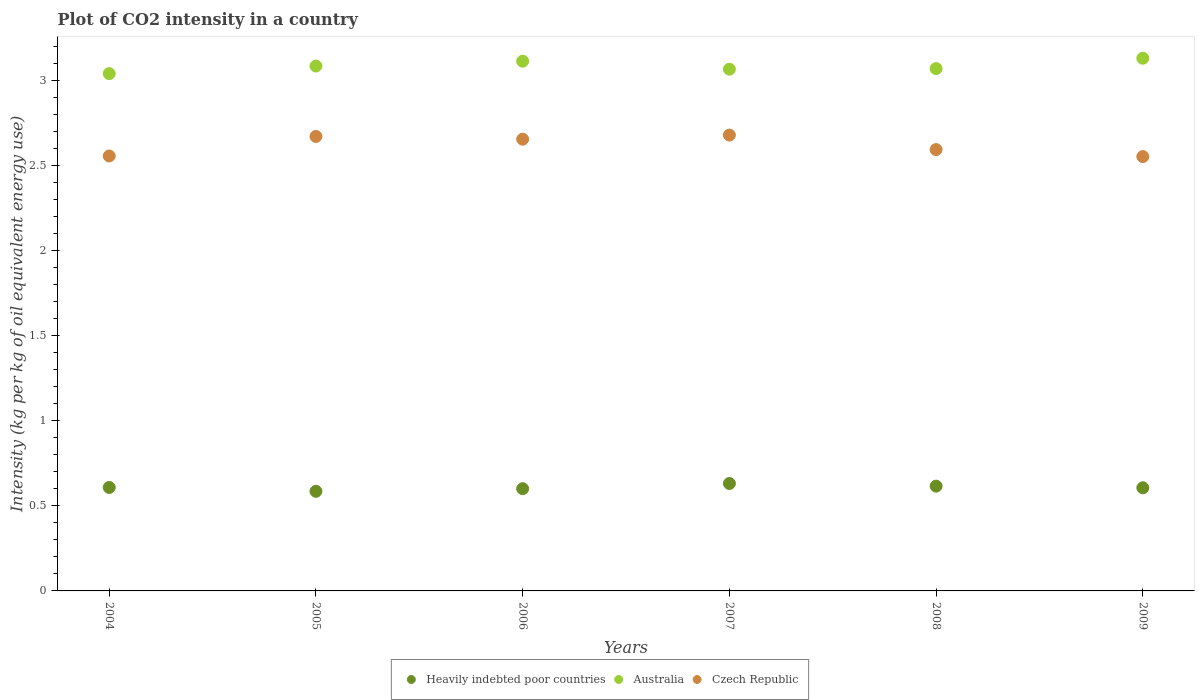Is the number of dotlines equal to the number of legend labels?
Give a very brief answer. Yes. What is the CO2 intensity in in Heavily indebted poor countries in 2009?
Make the answer very short. 0.61. Across all years, what is the maximum CO2 intensity in in Australia?
Give a very brief answer. 3.13. Across all years, what is the minimum CO2 intensity in in Czech Republic?
Give a very brief answer. 2.55. In which year was the CO2 intensity in in Heavily indebted poor countries maximum?
Offer a terse response. 2007. In which year was the CO2 intensity in in Australia minimum?
Offer a very short reply. 2004. What is the total CO2 intensity in in Australia in the graph?
Keep it short and to the point. 18.52. What is the difference between the CO2 intensity in in Czech Republic in 2008 and that in 2009?
Your response must be concise. 0.04. What is the difference between the CO2 intensity in in Czech Republic in 2004 and the CO2 intensity in in Australia in 2007?
Your answer should be very brief. -0.51. What is the average CO2 intensity in in Heavily indebted poor countries per year?
Your answer should be compact. 0.61. In the year 2007, what is the difference between the CO2 intensity in in Czech Republic and CO2 intensity in in Heavily indebted poor countries?
Offer a very short reply. 2.05. What is the ratio of the CO2 intensity in in Czech Republic in 2004 to that in 2006?
Give a very brief answer. 0.96. What is the difference between the highest and the second highest CO2 intensity in in Heavily indebted poor countries?
Offer a terse response. 0.02. What is the difference between the highest and the lowest CO2 intensity in in Australia?
Your answer should be very brief. 0.09. In how many years, is the CO2 intensity in in Heavily indebted poor countries greater than the average CO2 intensity in in Heavily indebted poor countries taken over all years?
Your response must be concise. 3. Is it the case that in every year, the sum of the CO2 intensity in in Australia and CO2 intensity in in Heavily indebted poor countries  is greater than the CO2 intensity in in Czech Republic?
Provide a short and direct response. Yes. How many dotlines are there?
Ensure brevity in your answer.  3. Does the graph contain any zero values?
Your answer should be very brief. No. What is the title of the graph?
Your answer should be compact. Plot of CO2 intensity in a country. What is the label or title of the Y-axis?
Give a very brief answer. Intensity (kg per kg of oil equivalent energy use). What is the Intensity (kg per kg of oil equivalent energy use) of Heavily indebted poor countries in 2004?
Offer a terse response. 0.61. What is the Intensity (kg per kg of oil equivalent energy use) in Australia in 2004?
Provide a succinct answer. 3.04. What is the Intensity (kg per kg of oil equivalent energy use) of Czech Republic in 2004?
Keep it short and to the point. 2.56. What is the Intensity (kg per kg of oil equivalent energy use) of Heavily indebted poor countries in 2005?
Your answer should be very brief. 0.59. What is the Intensity (kg per kg of oil equivalent energy use) of Australia in 2005?
Your answer should be very brief. 3.09. What is the Intensity (kg per kg of oil equivalent energy use) of Czech Republic in 2005?
Offer a very short reply. 2.67. What is the Intensity (kg per kg of oil equivalent energy use) of Heavily indebted poor countries in 2006?
Your response must be concise. 0.6. What is the Intensity (kg per kg of oil equivalent energy use) in Australia in 2006?
Provide a short and direct response. 3.12. What is the Intensity (kg per kg of oil equivalent energy use) of Czech Republic in 2006?
Offer a very short reply. 2.66. What is the Intensity (kg per kg of oil equivalent energy use) of Heavily indebted poor countries in 2007?
Give a very brief answer. 0.63. What is the Intensity (kg per kg of oil equivalent energy use) of Australia in 2007?
Ensure brevity in your answer.  3.07. What is the Intensity (kg per kg of oil equivalent energy use) in Czech Republic in 2007?
Provide a succinct answer. 2.68. What is the Intensity (kg per kg of oil equivalent energy use) in Heavily indebted poor countries in 2008?
Offer a terse response. 0.62. What is the Intensity (kg per kg of oil equivalent energy use) of Australia in 2008?
Provide a short and direct response. 3.07. What is the Intensity (kg per kg of oil equivalent energy use) of Czech Republic in 2008?
Keep it short and to the point. 2.6. What is the Intensity (kg per kg of oil equivalent energy use) of Heavily indebted poor countries in 2009?
Provide a succinct answer. 0.61. What is the Intensity (kg per kg of oil equivalent energy use) of Australia in 2009?
Ensure brevity in your answer.  3.13. What is the Intensity (kg per kg of oil equivalent energy use) of Czech Republic in 2009?
Your response must be concise. 2.55. Across all years, what is the maximum Intensity (kg per kg of oil equivalent energy use) in Heavily indebted poor countries?
Ensure brevity in your answer.  0.63. Across all years, what is the maximum Intensity (kg per kg of oil equivalent energy use) in Australia?
Offer a very short reply. 3.13. Across all years, what is the maximum Intensity (kg per kg of oil equivalent energy use) in Czech Republic?
Your response must be concise. 2.68. Across all years, what is the minimum Intensity (kg per kg of oil equivalent energy use) in Heavily indebted poor countries?
Provide a short and direct response. 0.59. Across all years, what is the minimum Intensity (kg per kg of oil equivalent energy use) of Australia?
Keep it short and to the point. 3.04. Across all years, what is the minimum Intensity (kg per kg of oil equivalent energy use) in Czech Republic?
Make the answer very short. 2.55. What is the total Intensity (kg per kg of oil equivalent energy use) in Heavily indebted poor countries in the graph?
Your answer should be very brief. 3.65. What is the total Intensity (kg per kg of oil equivalent energy use) in Australia in the graph?
Provide a short and direct response. 18.52. What is the total Intensity (kg per kg of oil equivalent energy use) of Czech Republic in the graph?
Your response must be concise. 15.72. What is the difference between the Intensity (kg per kg of oil equivalent energy use) in Heavily indebted poor countries in 2004 and that in 2005?
Give a very brief answer. 0.02. What is the difference between the Intensity (kg per kg of oil equivalent energy use) of Australia in 2004 and that in 2005?
Keep it short and to the point. -0.04. What is the difference between the Intensity (kg per kg of oil equivalent energy use) in Czech Republic in 2004 and that in 2005?
Ensure brevity in your answer.  -0.11. What is the difference between the Intensity (kg per kg of oil equivalent energy use) in Heavily indebted poor countries in 2004 and that in 2006?
Your answer should be very brief. 0.01. What is the difference between the Intensity (kg per kg of oil equivalent energy use) of Australia in 2004 and that in 2006?
Offer a terse response. -0.07. What is the difference between the Intensity (kg per kg of oil equivalent energy use) in Czech Republic in 2004 and that in 2006?
Your answer should be compact. -0.1. What is the difference between the Intensity (kg per kg of oil equivalent energy use) in Heavily indebted poor countries in 2004 and that in 2007?
Provide a succinct answer. -0.02. What is the difference between the Intensity (kg per kg of oil equivalent energy use) in Australia in 2004 and that in 2007?
Your response must be concise. -0.03. What is the difference between the Intensity (kg per kg of oil equivalent energy use) in Czech Republic in 2004 and that in 2007?
Ensure brevity in your answer.  -0.12. What is the difference between the Intensity (kg per kg of oil equivalent energy use) in Heavily indebted poor countries in 2004 and that in 2008?
Offer a terse response. -0.01. What is the difference between the Intensity (kg per kg of oil equivalent energy use) of Australia in 2004 and that in 2008?
Provide a succinct answer. -0.03. What is the difference between the Intensity (kg per kg of oil equivalent energy use) in Czech Republic in 2004 and that in 2008?
Give a very brief answer. -0.04. What is the difference between the Intensity (kg per kg of oil equivalent energy use) of Heavily indebted poor countries in 2004 and that in 2009?
Your response must be concise. 0. What is the difference between the Intensity (kg per kg of oil equivalent energy use) in Australia in 2004 and that in 2009?
Make the answer very short. -0.09. What is the difference between the Intensity (kg per kg of oil equivalent energy use) of Czech Republic in 2004 and that in 2009?
Your response must be concise. 0. What is the difference between the Intensity (kg per kg of oil equivalent energy use) in Heavily indebted poor countries in 2005 and that in 2006?
Your answer should be very brief. -0.02. What is the difference between the Intensity (kg per kg of oil equivalent energy use) in Australia in 2005 and that in 2006?
Make the answer very short. -0.03. What is the difference between the Intensity (kg per kg of oil equivalent energy use) of Czech Republic in 2005 and that in 2006?
Give a very brief answer. 0.02. What is the difference between the Intensity (kg per kg of oil equivalent energy use) in Heavily indebted poor countries in 2005 and that in 2007?
Keep it short and to the point. -0.05. What is the difference between the Intensity (kg per kg of oil equivalent energy use) in Australia in 2005 and that in 2007?
Your answer should be very brief. 0.02. What is the difference between the Intensity (kg per kg of oil equivalent energy use) in Czech Republic in 2005 and that in 2007?
Make the answer very short. -0.01. What is the difference between the Intensity (kg per kg of oil equivalent energy use) of Heavily indebted poor countries in 2005 and that in 2008?
Provide a succinct answer. -0.03. What is the difference between the Intensity (kg per kg of oil equivalent energy use) in Australia in 2005 and that in 2008?
Provide a short and direct response. 0.01. What is the difference between the Intensity (kg per kg of oil equivalent energy use) in Czech Republic in 2005 and that in 2008?
Your answer should be very brief. 0.08. What is the difference between the Intensity (kg per kg of oil equivalent energy use) in Heavily indebted poor countries in 2005 and that in 2009?
Make the answer very short. -0.02. What is the difference between the Intensity (kg per kg of oil equivalent energy use) of Australia in 2005 and that in 2009?
Your answer should be very brief. -0.05. What is the difference between the Intensity (kg per kg of oil equivalent energy use) of Czech Republic in 2005 and that in 2009?
Ensure brevity in your answer.  0.12. What is the difference between the Intensity (kg per kg of oil equivalent energy use) of Heavily indebted poor countries in 2006 and that in 2007?
Your answer should be compact. -0.03. What is the difference between the Intensity (kg per kg of oil equivalent energy use) of Australia in 2006 and that in 2007?
Offer a terse response. 0.05. What is the difference between the Intensity (kg per kg of oil equivalent energy use) of Czech Republic in 2006 and that in 2007?
Offer a terse response. -0.02. What is the difference between the Intensity (kg per kg of oil equivalent energy use) in Heavily indebted poor countries in 2006 and that in 2008?
Offer a terse response. -0.01. What is the difference between the Intensity (kg per kg of oil equivalent energy use) in Australia in 2006 and that in 2008?
Your answer should be compact. 0.04. What is the difference between the Intensity (kg per kg of oil equivalent energy use) in Czech Republic in 2006 and that in 2008?
Keep it short and to the point. 0.06. What is the difference between the Intensity (kg per kg of oil equivalent energy use) in Heavily indebted poor countries in 2006 and that in 2009?
Give a very brief answer. -0.01. What is the difference between the Intensity (kg per kg of oil equivalent energy use) in Australia in 2006 and that in 2009?
Your response must be concise. -0.02. What is the difference between the Intensity (kg per kg of oil equivalent energy use) in Czech Republic in 2006 and that in 2009?
Provide a short and direct response. 0.1. What is the difference between the Intensity (kg per kg of oil equivalent energy use) of Heavily indebted poor countries in 2007 and that in 2008?
Provide a succinct answer. 0.02. What is the difference between the Intensity (kg per kg of oil equivalent energy use) in Australia in 2007 and that in 2008?
Your answer should be very brief. -0. What is the difference between the Intensity (kg per kg of oil equivalent energy use) of Czech Republic in 2007 and that in 2008?
Your response must be concise. 0.09. What is the difference between the Intensity (kg per kg of oil equivalent energy use) of Heavily indebted poor countries in 2007 and that in 2009?
Ensure brevity in your answer.  0.03. What is the difference between the Intensity (kg per kg of oil equivalent energy use) of Australia in 2007 and that in 2009?
Provide a short and direct response. -0.06. What is the difference between the Intensity (kg per kg of oil equivalent energy use) of Czech Republic in 2007 and that in 2009?
Give a very brief answer. 0.13. What is the difference between the Intensity (kg per kg of oil equivalent energy use) of Heavily indebted poor countries in 2008 and that in 2009?
Your answer should be very brief. 0.01. What is the difference between the Intensity (kg per kg of oil equivalent energy use) of Australia in 2008 and that in 2009?
Offer a terse response. -0.06. What is the difference between the Intensity (kg per kg of oil equivalent energy use) of Czech Republic in 2008 and that in 2009?
Give a very brief answer. 0.04. What is the difference between the Intensity (kg per kg of oil equivalent energy use) of Heavily indebted poor countries in 2004 and the Intensity (kg per kg of oil equivalent energy use) of Australia in 2005?
Provide a succinct answer. -2.48. What is the difference between the Intensity (kg per kg of oil equivalent energy use) in Heavily indebted poor countries in 2004 and the Intensity (kg per kg of oil equivalent energy use) in Czech Republic in 2005?
Give a very brief answer. -2.06. What is the difference between the Intensity (kg per kg of oil equivalent energy use) of Australia in 2004 and the Intensity (kg per kg of oil equivalent energy use) of Czech Republic in 2005?
Give a very brief answer. 0.37. What is the difference between the Intensity (kg per kg of oil equivalent energy use) in Heavily indebted poor countries in 2004 and the Intensity (kg per kg of oil equivalent energy use) in Australia in 2006?
Offer a very short reply. -2.51. What is the difference between the Intensity (kg per kg of oil equivalent energy use) of Heavily indebted poor countries in 2004 and the Intensity (kg per kg of oil equivalent energy use) of Czech Republic in 2006?
Provide a succinct answer. -2.05. What is the difference between the Intensity (kg per kg of oil equivalent energy use) of Australia in 2004 and the Intensity (kg per kg of oil equivalent energy use) of Czech Republic in 2006?
Keep it short and to the point. 0.39. What is the difference between the Intensity (kg per kg of oil equivalent energy use) in Heavily indebted poor countries in 2004 and the Intensity (kg per kg of oil equivalent energy use) in Australia in 2007?
Offer a very short reply. -2.46. What is the difference between the Intensity (kg per kg of oil equivalent energy use) of Heavily indebted poor countries in 2004 and the Intensity (kg per kg of oil equivalent energy use) of Czech Republic in 2007?
Make the answer very short. -2.07. What is the difference between the Intensity (kg per kg of oil equivalent energy use) of Australia in 2004 and the Intensity (kg per kg of oil equivalent energy use) of Czech Republic in 2007?
Keep it short and to the point. 0.36. What is the difference between the Intensity (kg per kg of oil equivalent energy use) in Heavily indebted poor countries in 2004 and the Intensity (kg per kg of oil equivalent energy use) in Australia in 2008?
Make the answer very short. -2.46. What is the difference between the Intensity (kg per kg of oil equivalent energy use) of Heavily indebted poor countries in 2004 and the Intensity (kg per kg of oil equivalent energy use) of Czech Republic in 2008?
Offer a terse response. -1.99. What is the difference between the Intensity (kg per kg of oil equivalent energy use) in Australia in 2004 and the Intensity (kg per kg of oil equivalent energy use) in Czech Republic in 2008?
Your answer should be compact. 0.45. What is the difference between the Intensity (kg per kg of oil equivalent energy use) of Heavily indebted poor countries in 2004 and the Intensity (kg per kg of oil equivalent energy use) of Australia in 2009?
Offer a very short reply. -2.52. What is the difference between the Intensity (kg per kg of oil equivalent energy use) in Heavily indebted poor countries in 2004 and the Intensity (kg per kg of oil equivalent energy use) in Czech Republic in 2009?
Your answer should be compact. -1.95. What is the difference between the Intensity (kg per kg of oil equivalent energy use) of Australia in 2004 and the Intensity (kg per kg of oil equivalent energy use) of Czech Republic in 2009?
Offer a terse response. 0.49. What is the difference between the Intensity (kg per kg of oil equivalent energy use) in Heavily indebted poor countries in 2005 and the Intensity (kg per kg of oil equivalent energy use) in Australia in 2006?
Keep it short and to the point. -2.53. What is the difference between the Intensity (kg per kg of oil equivalent energy use) in Heavily indebted poor countries in 2005 and the Intensity (kg per kg of oil equivalent energy use) in Czech Republic in 2006?
Your response must be concise. -2.07. What is the difference between the Intensity (kg per kg of oil equivalent energy use) in Australia in 2005 and the Intensity (kg per kg of oil equivalent energy use) in Czech Republic in 2006?
Keep it short and to the point. 0.43. What is the difference between the Intensity (kg per kg of oil equivalent energy use) of Heavily indebted poor countries in 2005 and the Intensity (kg per kg of oil equivalent energy use) of Australia in 2007?
Give a very brief answer. -2.48. What is the difference between the Intensity (kg per kg of oil equivalent energy use) of Heavily indebted poor countries in 2005 and the Intensity (kg per kg of oil equivalent energy use) of Czech Republic in 2007?
Ensure brevity in your answer.  -2.1. What is the difference between the Intensity (kg per kg of oil equivalent energy use) of Australia in 2005 and the Intensity (kg per kg of oil equivalent energy use) of Czech Republic in 2007?
Offer a very short reply. 0.41. What is the difference between the Intensity (kg per kg of oil equivalent energy use) in Heavily indebted poor countries in 2005 and the Intensity (kg per kg of oil equivalent energy use) in Australia in 2008?
Ensure brevity in your answer.  -2.49. What is the difference between the Intensity (kg per kg of oil equivalent energy use) in Heavily indebted poor countries in 2005 and the Intensity (kg per kg of oil equivalent energy use) in Czech Republic in 2008?
Offer a terse response. -2.01. What is the difference between the Intensity (kg per kg of oil equivalent energy use) of Australia in 2005 and the Intensity (kg per kg of oil equivalent energy use) of Czech Republic in 2008?
Offer a very short reply. 0.49. What is the difference between the Intensity (kg per kg of oil equivalent energy use) in Heavily indebted poor countries in 2005 and the Intensity (kg per kg of oil equivalent energy use) in Australia in 2009?
Keep it short and to the point. -2.55. What is the difference between the Intensity (kg per kg of oil equivalent energy use) in Heavily indebted poor countries in 2005 and the Intensity (kg per kg of oil equivalent energy use) in Czech Republic in 2009?
Provide a succinct answer. -1.97. What is the difference between the Intensity (kg per kg of oil equivalent energy use) of Australia in 2005 and the Intensity (kg per kg of oil equivalent energy use) of Czech Republic in 2009?
Provide a succinct answer. 0.53. What is the difference between the Intensity (kg per kg of oil equivalent energy use) of Heavily indebted poor countries in 2006 and the Intensity (kg per kg of oil equivalent energy use) of Australia in 2007?
Provide a succinct answer. -2.47. What is the difference between the Intensity (kg per kg of oil equivalent energy use) in Heavily indebted poor countries in 2006 and the Intensity (kg per kg of oil equivalent energy use) in Czech Republic in 2007?
Provide a succinct answer. -2.08. What is the difference between the Intensity (kg per kg of oil equivalent energy use) of Australia in 2006 and the Intensity (kg per kg of oil equivalent energy use) of Czech Republic in 2007?
Offer a very short reply. 0.43. What is the difference between the Intensity (kg per kg of oil equivalent energy use) in Heavily indebted poor countries in 2006 and the Intensity (kg per kg of oil equivalent energy use) in Australia in 2008?
Your response must be concise. -2.47. What is the difference between the Intensity (kg per kg of oil equivalent energy use) of Heavily indebted poor countries in 2006 and the Intensity (kg per kg of oil equivalent energy use) of Czech Republic in 2008?
Make the answer very short. -1.99. What is the difference between the Intensity (kg per kg of oil equivalent energy use) in Australia in 2006 and the Intensity (kg per kg of oil equivalent energy use) in Czech Republic in 2008?
Provide a succinct answer. 0.52. What is the difference between the Intensity (kg per kg of oil equivalent energy use) in Heavily indebted poor countries in 2006 and the Intensity (kg per kg of oil equivalent energy use) in Australia in 2009?
Keep it short and to the point. -2.53. What is the difference between the Intensity (kg per kg of oil equivalent energy use) of Heavily indebted poor countries in 2006 and the Intensity (kg per kg of oil equivalent energy use) of Czech Republic in 2009?
Offer a very short reply. -1.95. What is the difference between the Intensity (kg per kg of oil equivalent energy use) in Australia in 2006 and the Intensity (kg per kg of oil equivalent energy use) in Czech Republic in 2009?
Offer a terse response. 0.56. What is the difference between the Intensity (kg per kg of oil equivalent energy use) of Heavily indebted poor countries in 2007 and the Intensity (kg per kg of oil equivalent energy use) of Australia in 2008?
Offer a very short reply. -2.44. What is the difference between the Intensity (kg per kg of oil equivalent energy use) in Heavily indebted poor countries in 2007 and the Intensity (kg per kg of oil equivalent energy use) in Czech Republic in 2008?
Provide a short and direct response. -1.96. What is the difference between the Intensity (kg per kg of oil equivalent energy use) in Australia in 2007 and the Intensity (kg per kg of oil equivalent energy use) in Czech Republic in 2008?
Keep it short and to the point. 0.47. What is the difference between the Intensity (kg per kg of oil equivalent energy use) of Heavily indebted poor countries in 2007 and the Intensity (kg per kg of oil equivalent energy use) of Australia in 2009?
Ensure brevity in your answer.  -2.5. What is the difference between the Intensity (kg per kg of oil equivalent energy use) in Heavily indebted poor countries in 2007 and the Intensity (kg per kg of oil equivalent energy use) in Czech Republic in 2009?
Ensure brevity in your answer.  -1.92. What is the difference between the Intensity (kg per kg of oil equivalent energy use) of Australia in 2007 and the Intensity (kg per kg of oil equivalent energy use) of Czech Republic in 2009?
Give a very brief answer. 0.51. What is the difference between the Intensity (kg per kg of oil equivalent energy use) of Heavily indebted poor countries in 2008 and the Intensity (kg per kg of oil equivalent energy use) of Australia in 2009?
Keep it short and to the point. -2.52. What is the difference between the Intensity (kg per kg of oil equivalent energy use) in Heavily indebted poor countries in 2008 and the Intensity (kg per kg of oil equivalent energy use) in Czech Republic in 2009?
Offer a very short reply. -1.94. What is the difference between the Intensity (kg per kg of oil equivalent energy use) of Australia in 2008 and the Intensity (kg per kg of oil equivalent energy use) of Czech Republic in 2009?
Your response must be concise. 0.52. What is the average Intensity (kg per kg of oil equivalent energy use) of Heavily indebted poor countries per year?
Make the answer very short. 0.61. What is the average Intensity (kg per kg of oil equivalent energy use) in Australia per year?
Ensure brevity in your answer.  3.09. What is the average Intensity (kg per kg of oil equivalent energy use) of Czech Republic per year?
Offer a terse response. 2.62. In the year 2004, what is the difference between the Intensity (kg per kg of oil equivalent energy use) in Heavily indebted poor countries and Intensity (kg per kg of oil equivalent energy use) in Australia?
Keep it short and to the point. -2.43. In the year 2004, what is the difference between the Intensity (kg per kg of oil equivalent energy use) in Heavily indebted poor countries and Intensity (kg per kg of oil equivalent energy use) in Czech Republic?
Give a very brief answer. -1.95. In the year 2004, what is the difference between the Intensity (kg per kg of oil equivalent energy use) of Australia and Intensity (kg per kg of oil equivalent energy use) of Czech Republic?
Give a very brief answer. 0.48. In the year 2005, what is the difference between the Intensity (kg per kg of oil equivalent energy use) in Heavily indebted poor countries and Intensity (kg per kg of oil equivalent energy use) in Australia?
Give a very brief answer. -2.5. In the year 2005, what is the difference between the Intensity (kg per kg of oil equivalent energy use) of Heavily indebted poor countries and Intensity (kg per kg of oil equivalent energy use) of Czech Republic?
Give a very brief answer. -2.09. In the year 2005, what is the difference between the Intensity (kg per kg of oil equivalent energy use) of Australia and Intensity (kg per kg of oil equivalent energy use) of Czech Republic?
Make the answer very short. 0.41. In the year 2006, what is the difference between the Intensity (kg per kg of oil equivalent energy use) in Heavily indebted poor countries and Intensity (kg per kg of oil equivalent energy use) in Australia?
Make the answer very short. -2.51. In the year 2006, what is the difference between the Intensity (kg per kg of oil equivalent energy use) in Heavily indebted poor countries and Intensity (kg per kg of oil equivalent energy use) in Czech Republic?
Make the answer very short. -2.06. In the year 2006, what is the difference between the Intensity (kg per kg of oil equivalent energy use) of Australia and Intensity (kg per kg of oil equivalent energy use) of Czech Republic?
Provide a short and direct response. 0.46. In the year 2007, what is the difference between the Intensity (kg per kg of oil equivalent energy use) in Heavily indebted poor countries and Intensity (kg per kg of oil equivalent energy use) in Australia?
Give a very brief answer. -2.44. In the year 2007, what is the difference between the Intensity (kg per kg of oil equivalent energy use) of Heavily indebted poor countries and Intensity (kg per kg of oil equivalent energy use) of Czech Republic?
Provide a succinct answer. -2.05. In the year 2007, what is the difference between the Intensity (kg per kg of oil equivalent energy use) in Australia and Intensity (kg per kg of oil equivalent energy use) in Czech Republic?
Keep it short and to the point. 0.39. In the year 2008, what is the difference between the Intensity (kg per kg of oil equivalent energy use) of Heavily indebted poor countries and Intensity (kg per kg of oil equivalent energy use) of Australia?
Provide a short and direct response. -2.46. In the year 2008, what is the difference between the Intensity (kg per kg of oil equivalent energy use) of Heavily indebted poor countries and Intensity (kg per kg of oil equivalent energy use) of Czech Republic?
Keep it short and to the point. -1.98. In the year 2008, what is the difference between the Intensity (kg per kg of oil equivalent energy use) in Australia and Intensity (kg per kg of oil equivalent energy use) in Czech Republic?
Offer a terse response. 0.48. In the year 2009, what is the difference between the Intensity (kg per kg of oil equivalent energy use) of Heavily indebted poor countries and Intensity (kg per kg of oil equivalent energy use) of Australia?
Give a very brief answer. -2.53. In the year 2009, what is the difference between the Intensity (kg per kg of oil equivalent energy use) in Heavily indebted poor countries and Intensity (kg per kg of oil equivalent energy use) in Czech Republic?
Keep it short and to the point. -1.95. In the year 2009, what is the difference between the Intensity (kg per kg of oil equivalent energy use) in Australia and Intensity (kg per kg of oil equivalent energy use) in Czech Republic?
Provide a short and direct response. 0.58. What is the ratio of the Intensity (kg per kg of oil equivalent energy use) in Heavily indebted poor countries in 2004 to that in 2005?
Your response must be concise. 1.04. What is the ratio of the Intensity (kg per kg of oil equivalent energy use) in Australia in 2004 to that in 2005?
Keep it short and to the point. 0.99. What is the ratio of the Intensity (kg per kg of oil equivalent energy use) in Czech Republic in 2004 to that in 2005?
Provide a succinct answer. 0.96. What is the ratio of the Intensity (kg per kg of oil equivalent energy use) in Heavily indebted poor countries in 2004 to that in 2006?
Give a very brief answer. 1.01. What is the ratio of the Intensity (kg per kg of oil equivalent energy use) of Australia in 2004 to that in 2006?
Your answer should be very brief. 0.98. What is the ratio of the Intensity (kg per kg of oil equivalent energy use) in Czech Republic in 2004 to that in 2006?
Your answer should be very brief. 0.96. What is the ratio of the Intensity (kg per kg of oil equivalent energy use) in Heavily indebted poor countries in 2004 to that in 2007?
Make the answer very short. 0.96. What is the ratio of the Intensity (kg per kg of oil equivalent energy use) in Australia in 2004 to that in 2007?
Offer a terse response. 0.99. What is the ratio of the Intensity (kg per kg of oil equivalent energy use) of Czech Republic in 2004 to that in 2007?
Your answer should be compact. 0.95. What is the ratio of the Intensity (kg per kg of oil equivalent energy use) in Heavily indebted poor countries in 2004 to that in 2008?
Provide a succinct answer. 0.99. What is the ratio of the Intensity (kg per kg of oil equivalent energy use) of Australia in 2004 to that in 2008?
Provide a succinct answer. 0.99. What is the ratio of the Intensity (kg per kg of oil equivalent energy use) in Czech Republic in 2004 to that in 2008?
Offer a terse response. 0.99. What is the ratio of the Intensity (kg per kg of oil equivalent energy use) of Australia in 2004 to that in 2009?
Your response must be concise. 0.97. What is the ratio of the Intensity (kg per kg of oil equivalent energy use) of Heavily indebted poor countries in 2005 to that in 2006?
Make the answer very short. 0.97. What is the ratio of the Intensity (kg per kg of oil equivalent energy use) of Czech Republic in 2005 to that in 2006?
Your response must be concise. 1.01. What is the ratio of the Intensity (kg per kg of oil equivalent energy use) of Heavily indebted poor countries in 2005 to that in 2007?
Your response must be concise. 0.93. What is the ratio of the Intensity (kg per kg of oil equivalent energy use) in Australia in 2005 to that in 2007?
Keep it short and to the point. 1.01. What is the ratio of the Intensity (kg per kg of oil equivalent energy use) in Czech Republic in 2005 to that in 2007?
Make the answer very short. 1. What is the ratio of the Intensity (kg per kg of oil equivalent energy use) of Heavily indebted poor countries in 2005 to that in 2008?
Provide a short and direct response. 0.95. What is the ratio of the Intensity (kg per kg of oil equivalent energy use) of Australia in 2005 to that in 2008?
Keep it short and to the point. 1. What is the ratio of the Intensity (kg per kg of oil equivalent energy use) of Czech Republic in 2005 to that in 2008?
Your answer should be compact. 1.03. What is the ratio of the Intensity (kg per kg of oil equivalent energy use) in Heavily indebted poor countries in 2005 to that in 2009?
Offer a terse response. 0.97. What is the ratio of the Intensity (kg per kg of oil equivalent energy use) of Czech Republic in 2005 to that in 2009?
Your response must be concise. 1.05. What is the ratio of the Intensity (kg per kg of oil equivalent energy use) in Heavily indebted poor countries in 2006 to that in 2007?
Give a very brief answer. 0.95. What is the ratio of the Intensity (kg per kg of oil equivalent energy use) in Australia in 2006 to that in 2007?
Provide a short and direct response. 1.02. What is the ratio of the Intensity (kg per kg of oil equivalent energy use) in Heavily indebted poor countries in 2006 to that in 2008?
Keep it short and to the point. 0.98. What is the ratio of the Intensity (kg per kg of oil equivalent energy use) of Australia in 2006 to that in 2008?
Ensure brevity in your answer.  1.01. What is the ratio of the Intensity (kg per kg of oil equivalent energy use) in Czech Republic in 2006 to that in 2008?
Your answer should be very brief. 1.02. What is the ratio of the Intensity (kg per kg of oil equivalent energy use) of Heavily indebted poor countries in 2007 to that in 2008?
Make the answer very short. 1.03. What is the ratio of the Intensity (kg per kg of oil equivalent energy use) in Czech Republic in 2007 to that in 2008?
Keep it short and to the point. 1.03. What is the ratio of the Intensity (kg per kg of oil equivalent energy use) in Heavily indebted poor countries in 2007 to that in 2009?
Make the answer very short. 1.04. What is the ratio of the Intensity (kg per kg of oil equivalent energy use) of Australia in 2007 to that in 2009?
Offer a terse response. 0.98. What is the ratio of the Intensity (kg per kg of oil equivalent energy use) in Czech Republic in 2007 to that in 2009?
Make the answer very short. 1.05. What is the ratio of the Intensity (kg per kg of oil equivalent energy use) of Heavily indebted poor countries in 2008 to that in 2009?
Your answer should be compact. 1.02. What is the ratio of the Intensity (kg per kg of oil equivalent energy use) of Australia in 2008 to that in 2009?
Provide a succinct answer. 0.98. What is the ratio of the Intensity (kg per kg of oil equivalent energy use) in Czech Republic in 2008 to that in 2009?
Your answer should be compact. 1.02. What is the difference between the highest and the second highest Intensity (kg per kg of oil equivalent energy use) of Heavily indebted poor countries?
Offer a very short reply. 0.02. What is the difference between the highest and the second highest Intensity (kg per kg of oil equivalent energy use) of Australia?
Give a very brief answer. 0.02. What is the difference between the highest and the second highest Intensity (kg per kg of oil equivalent energy use) of Czech Republic?
Offer a terse response. 0.01. What is the difference between the highest and the lowest Intensity (kg per kg of oil equivalent energy use) of Heavily indebted poor countries?
Your answer should be very brief. 0.05. What is the difference between the highest and the lowest Intensity (kg per kg of oil equivalent energy use) in Australia?
Ensure brevity in your answer.  0.09. What is the difference between the highest and the lowest Intensity (kg per kg of oil equivalent energy use) of Czech Republic?
Keep it short and to the point. 0.13. 